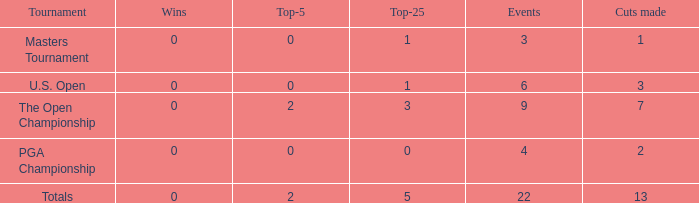What is the cumulative number of wins in events with below 2 top-5s, under 5 top-25s, and participation in more than 4 events? 1.0. 